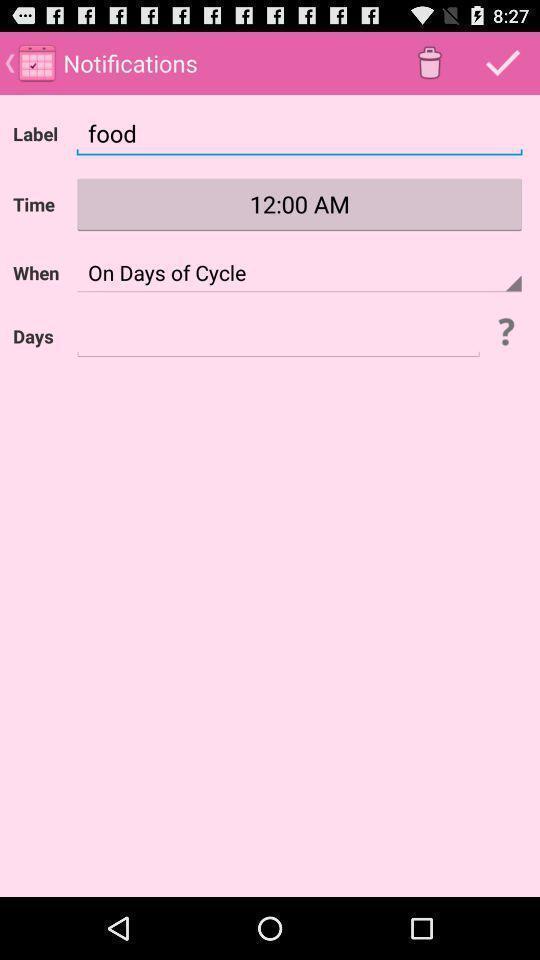Provide a textual representation of this image. Screen displaying multiple options in notification page. 